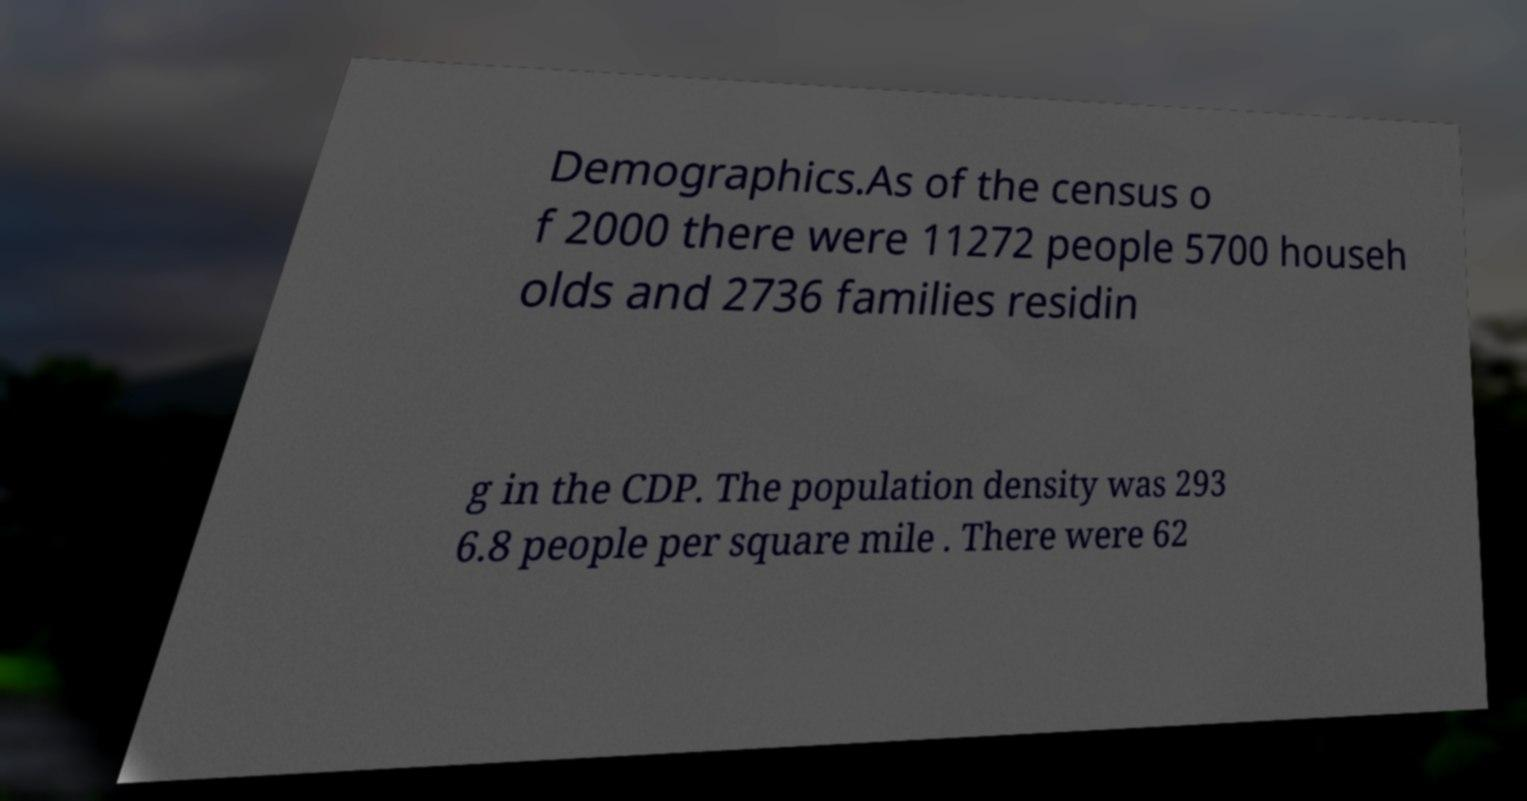There's text embedded in this image that I need extracted. Can you transcribe it verbatim? Demographics.As of the census o f 2000 there were 11272 people 5700 househ olds and 2736 families residin g in the CDP. The population density was 293 6.8 people per square mile . There were 62 